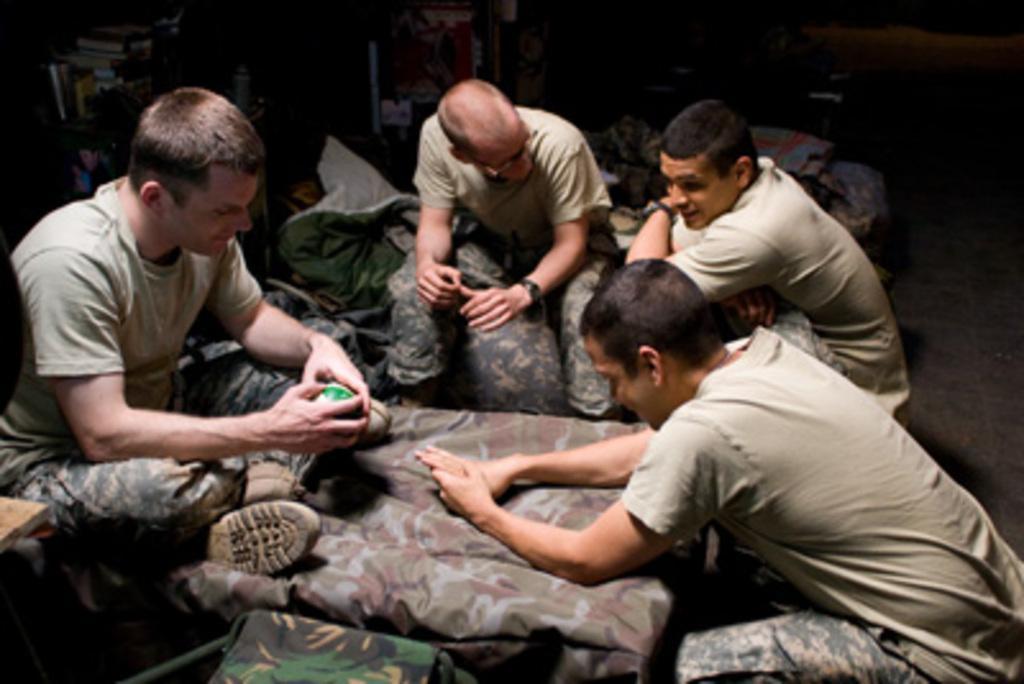Could you give a brief overview of what you see in this image? In this picture there are soldiers, beds and other objects. In the background there are shelves and books. 